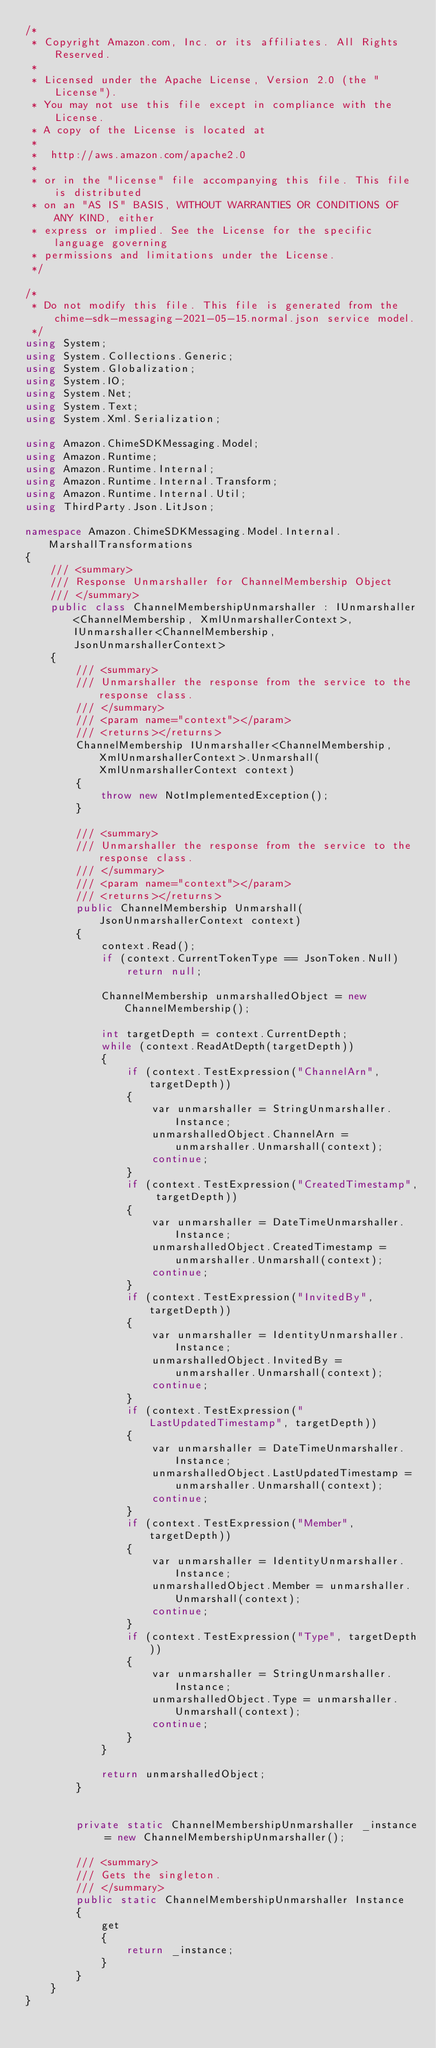<code> <loc_0><loc_0><loc_500><loc_500><_C#_>/*
 * Copyright Amazon.com, Inc. or its affiliates. All Rights Reserved.
 * 
 * Licensed under the Apache License, Version 2.0 (the "License").
 * You may not use this file except in compliance with the License.
 * A copy of the License is located at
 * 
 *  http://aws.amazon.com/apache2.0
 * 
 * or in the "license" file accompanying this file. This file is distributed
 * on an "AS IS" BASIS, WITHOUT WARRANTIES OR CONDITIONS OF ANY KIND, either
 * express or implied. See the License for the specific language governing
 * permissions and limitations under the License.
 */

/*
 * Do not modify this file. This file is generated from the chime-sdk-messaging-2021-05-15.normal.json service model.
 */
using System;
using System.Collections.Generic;
using System.Globalization;
using System.IO;
using System.Net;
using System.Text;
using System.Xml.Serialization;

using Amazon.ChimeSDKMessaging.Model;
using Amazon.Runtime;
using Amazon.Runtime.Internal;
using Amazon.Runtime.Internal.Transform;
using Amazon.Runtime.Internal.Util;
using ThirdParty.Json.LitJson;

namespace Amazon.ChimeSDKMessaging.Model.Internal.MarshallTransformations
{
    /// <summary>
    /// Response Unmarshaller for ChannelMembership Object
    /// </summary>  
    public class ChannelMembershipUnmarshaller : IUnmarshaller<ChannelMembership, XmlUnmarshallerContext>, IUnmarshaller<ChannelMembership, JsonUnmarshallerContext>
    {
        /// <summary>
        /// Unmarshaller the response from the service to the response class.
        /// </summary>  
        /// <param name="context"></param>
        /// <returns></returns>
        ChannelMembership IUnmarshaller<ChannelMembership, XmlUnmarshallerContext>.Unmarshall(XmlUnmarshallerContext context)
        {
            throw new NotImplementedException();
        }

        /// <summary>
        /// Unmarshaller the response from the service to the response class.
        /// </summary>  
        /// <param name="context"></param>
        /// <returns></returns>
        public ChannelMembership Unmarshall(JsonUnmarshallerContext context)
        {
            context.Read();
            if (context.CurrentTokenType == JsonToken.Null) 
                return null;

            ChannelMembership unmarshalledObject = new ChannelMembership();
        
            int targetDepth = context.CurrentDepth;
            while (context.ReadAtDepth(targetDepth))
            {
                if (context.TestExpression("ChannelArn", targetDepth))
                {
                    var unmarshaller = StringUnmarshaller.Instance;
                    unmarshalledObject.ChannelArn = unmarshaller.Unmarshall(context);
                    continue;
                }
                if (context.TestExpression("CreatedTimestamp", targetDepth))
                {
                    var unmarshaller = DateTimeUnmarshaller.Instance;
                    unmarshalledObject.CreatedTimestamp = unmarshaller.Unmarshall(context);
                    continue;
                }
                if (context.TestExpression("InvitedBy", targetDepth))
                {
                    var unmarshaller = IdentityUnmarshaller.Instance;
                    unmarshalledObject.InvitedBy = unmarshaller.Unmarshall(context);
                    continue;
                }
                if (context.TestExpression("LastUpdatedTimestamp", targetDepth))
                {
                    var unmarshaller = DateTimeUnmarshaller.Instance;
                    unmarshalledObject.LastUpdatedTimestamp = unmarshaller.Unmarshall(context);
                    continue;
                }
                if (context.TestExpression("Member", targetDepth))
                {
                    var unmarshaller = IdentityUnmarshaller.Instance;
                    unmarshalledObject.Member = unmarshaller.Unmarshall(context);
                    continue;
                }
                if (context.TestExpression("Type", targetDepth))
                {
                    var unmarshaller = StringUnmarshaller.Instance;
                    unmarshalledObject.Type = unmarshaller.Unmarshall(context);
                    continue;
                }
            }
          
            return unmarshalledObject;
        }


        private static ChannelMembershipUnmarshaller _instance = new ChannelMembershipUnmarshaller();        

        /// <summary>
        /// Gets the singleton.
        /// </summary>  
        public static ChannelMembershipUnmarshaller Instance
        {
            get
            {
                return _instance;
            }
        }
    }
}</code> 